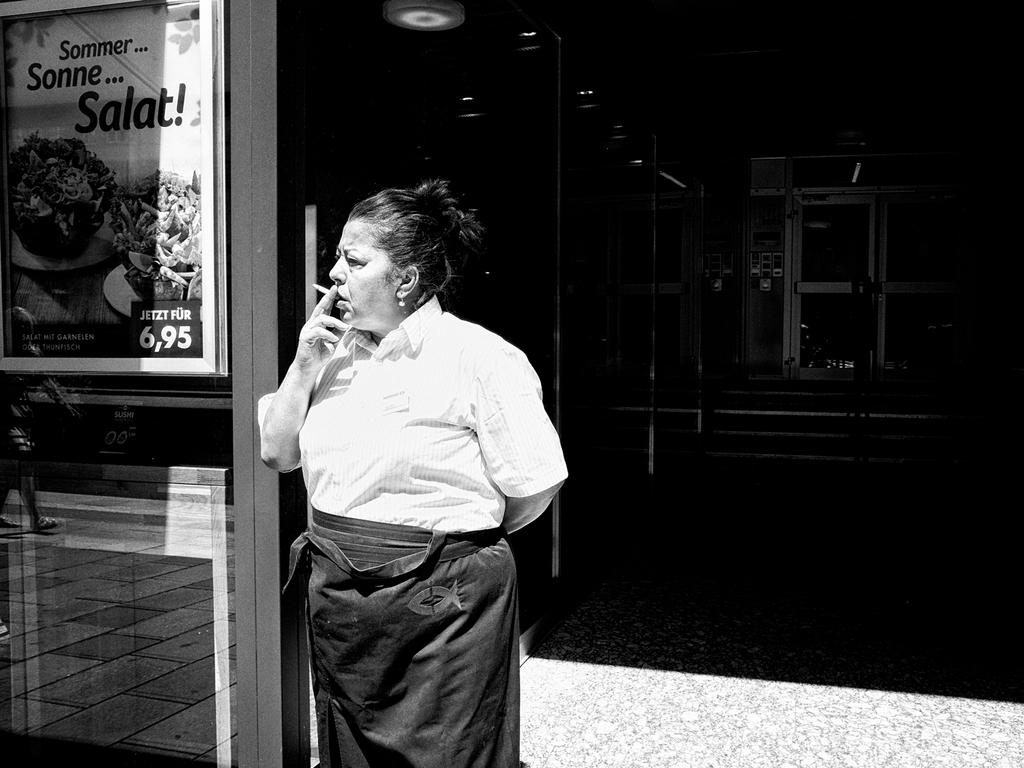What is the person in the image doing? The person is holding a cigarette. What can be seen on the glass beside the person? There is a board with text and images on the glass beside the person. What is visible in the background of the image? There is a building and stairs in the background of the image. What type of leaf is falling through the gate in the image? There is no leaf or gate present in the image. How many quarters can be seen on the person's clothing in the image? There are no quarters visible on the person's clothing in the image. 